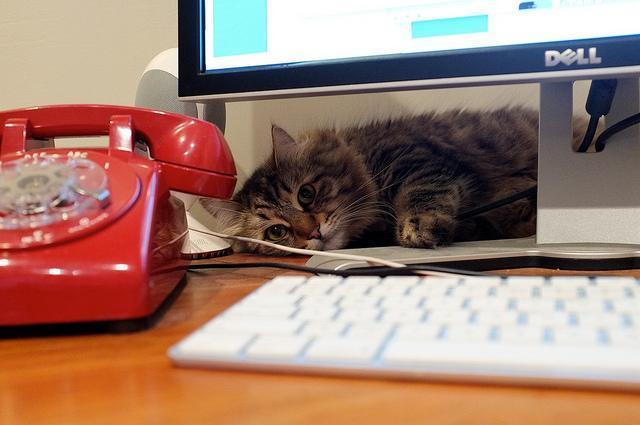How many horses are depicted?
Give a very brief answer. 0. 